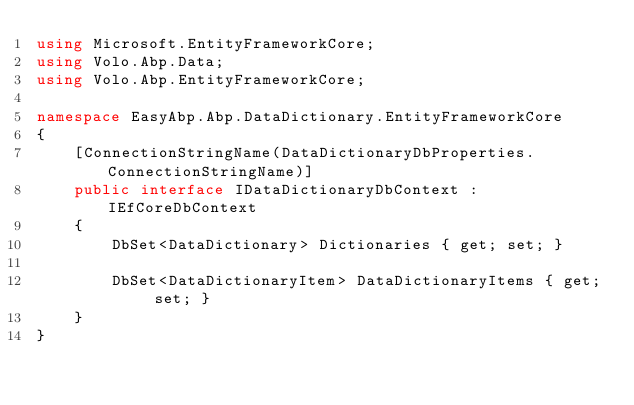<code> <loc_0><loc_0><loc_500><loc_500><_C#_>using Microsoft.EntityFrameworkCore;
using Volo.Abp.Data;
using Volo.Abp.EntityFrameworkCore;

namespace EasyAbp.Abp.DataDictionary.EntityFrameworkCore
{
    [ConnectionStringName(DataDictionaryDbProperties.ConnectionStringName)]
    public interface IDataDictionaryDbContext : IEfCoreDbContext
    {
        DbSet<DataDictionary> Dictionaries { get; set; }

        DbSet<DataDictionaryItem> DataDictionaryItems { get; set; }
    }
}</code> 